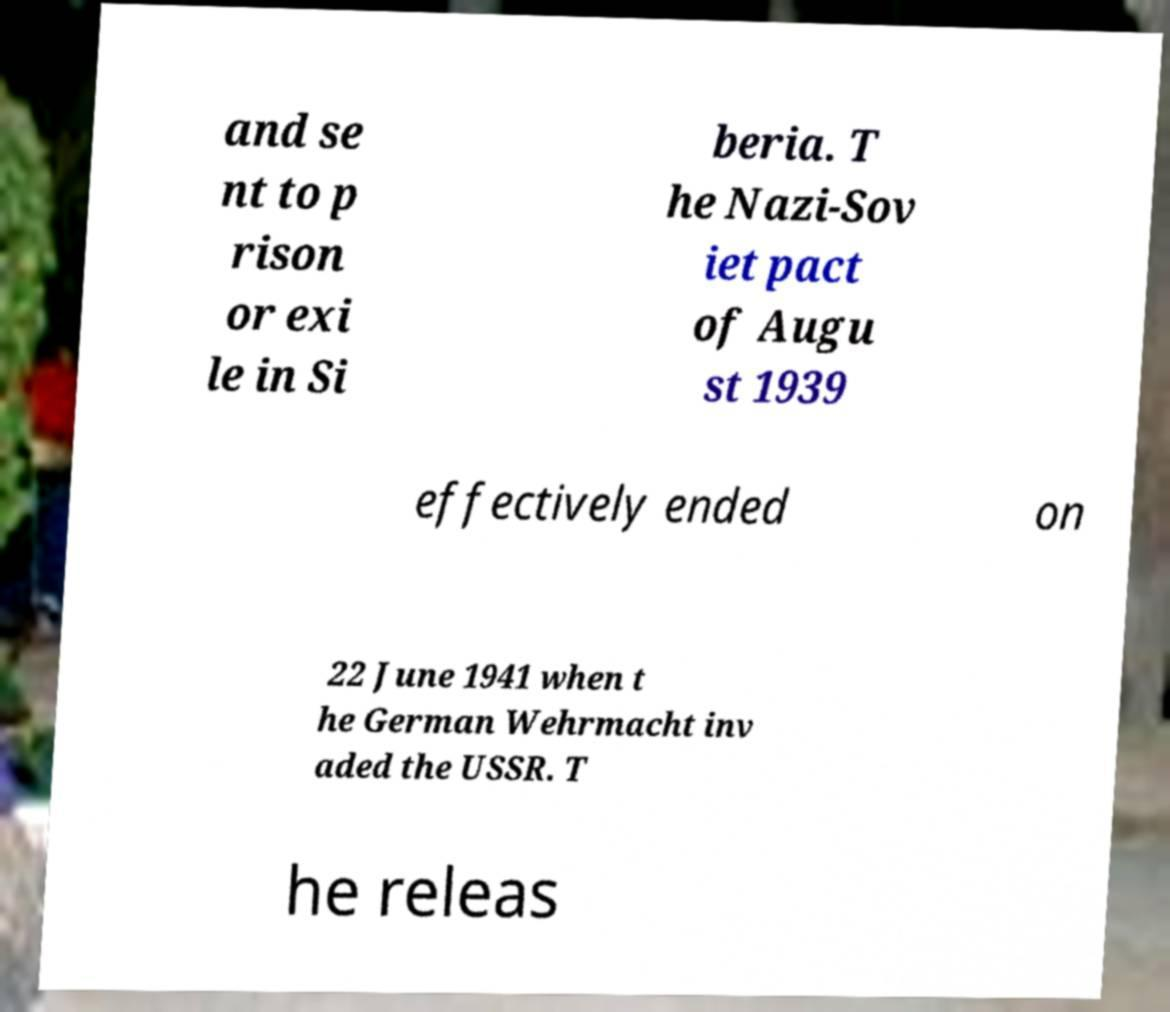Could you extract and type out the text from this image? and se nt to p rison or exi le in Si beria. T he Nazi-Sov iet pact of Augu st 1939 effectively ended on 22 June 1941 when t he German Wehrmacht inv aded the USSR. T he releas 